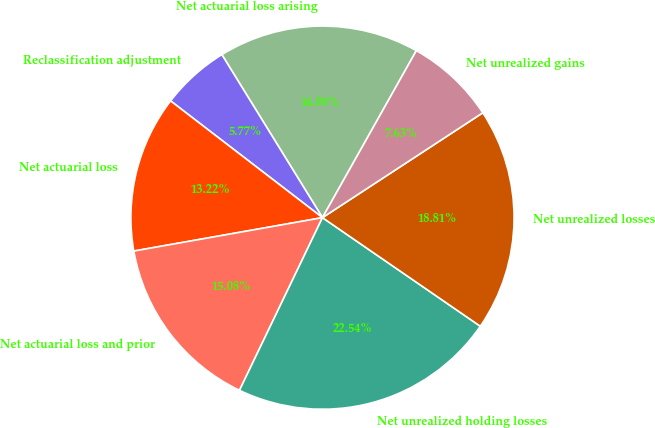Convert chart to OTSL. <chart><loc_0><loc_0><loc_500><loc_500><pie_chart><fcel>Net actuarial loss arising<fcel>Reclassification adjustment<fcel>Net actuarial loss<fcel>Net actuarial loss and prior<fcel>Net unrealized holding losses<fcel>Net unrealized losses<fcel>Net unrealized gains<nl><fcel>16.95%<fcel>5.77%<fcel>13.22%<fcel>15.08%<fcel>22.54%<fcel>18.81%<fcel>7.63%<nl></chart> 